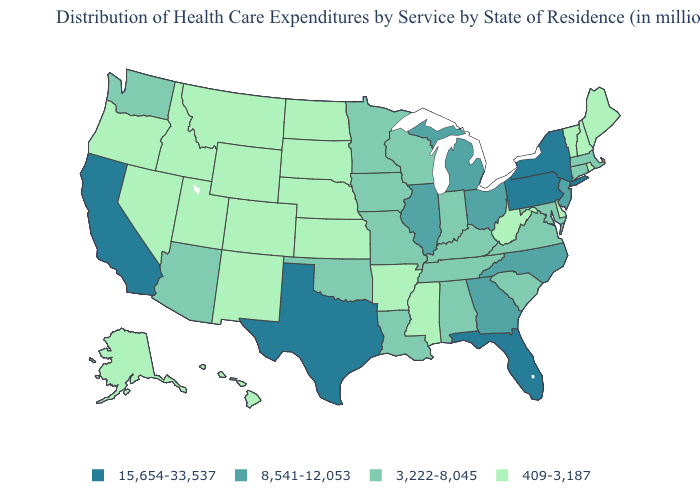Does the first symbol in the legend represent the smallest category?
Be succinct. No. What is the value of Arkansas?
Write a very short answer. 409-3,187. Among the states that border North Carolina , does Tennessee have the lowest value?
Concise answer only. Yes. How many symbols are there in the legend?
Be succinct. 4. What is the value of New Mexico?
Write a very short answer. 409-3,187. Which states have the highest value in the USA?
Answer briefly. California, Florida, New York, Pennsylvania, Texas. Name the states that have a value in the range 409-3,187?
Quick response, please. Alaska, Arkansas, Colorado, Delaware, Hawaii, Idaho, Kansas, Maine, Mississippi, Montana, Nebraska, Nevada, New Hampshire, New Mexico, North Dakota, Oregon, Rhode Island, South Dakota, Utah, Vermont, West Virginia, Wyoming. Name the states that have a value in the range 409-3,187?
Short answer required. Alaska, Arkansas, Colorado, Delaware, Hawaii, Idaho, Kansas, Maine, Mississippi, Montana, Nebraska, Nevada, New Hampshire, New Mexico, North Dakota, Oregon, Rhode Island, South Dakota, Utah, Vermont, West Virginia, Wyoming. What is the value of Connecticut?
Short answer required. 3,222-8,045. Does Massachusetts have the highest value in the Northeast?
Quick response, please. No. Name the states that have a value in the range 15,654-33,537?
Concise answer only. California, Florida, New York, Pennsylvania, Texas. Does Nevada have a lower value than Michigan?
Keep it brief. Yes. Does Rhode Island have a lower value than Wyoming?
Give a very brief answer. No. Does the map have missing data?
Short answer required. No. What is the highest value in the USA?
Quick response, please. 15,654-33,537. 